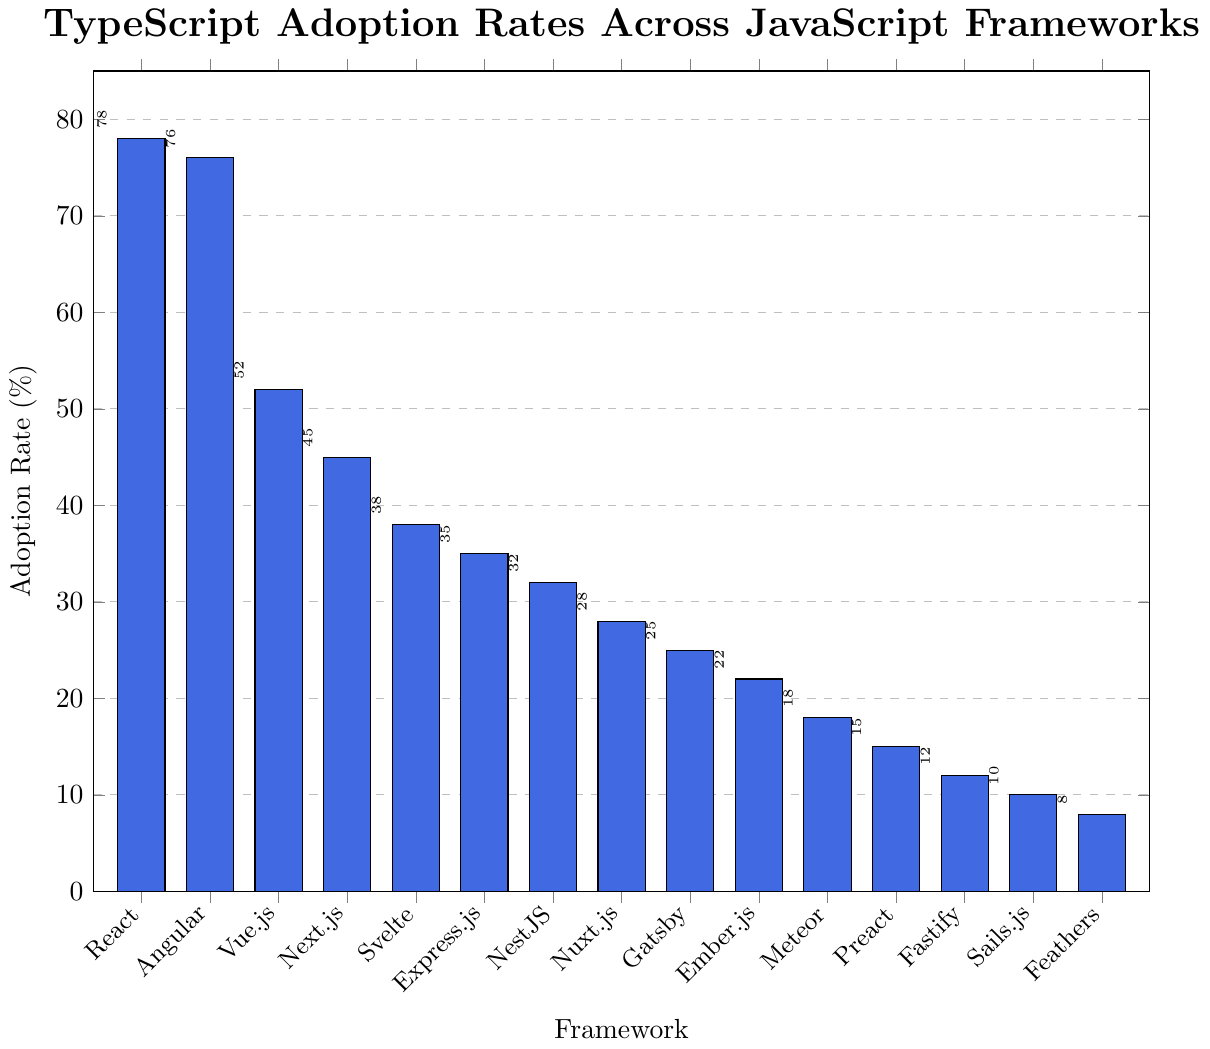What's the framework with the highest TypeScript adoption rate? The highest bar in the chart corresponds to the framework with the highest adoption rate. In this case, the tallest bar represents React with an adoption rate of 78%.
Answer: React Which framework has a lower TypeScript adoption rate, Angular or Vue.js? To determine which framework has a lower adoption rate, compare the heights of the bars for Angular and Vue.js. Angular has an adoption rate of 76%, while Vue.js has 52%. Hence, Vue.js has a lower adoption rate.
Answer: Vue.js What is the total adoption rate for the top three frameworks? The top three frameworks in terms of adoption rate are React (78%), Angular (76%), and Vue.js (52%). Summing these values: 78% + 76% + 52% = 206%.
Answer: 206% How much higher is Next.js's adoption rate compared to Fastify's? Subtract the adoption rate of Fastify (12%) from that of Next.js (45%): 45% - 12% = 33%. Thus, Next.js's adoption rate is 33% higher than Fastify's.
Answer: 33% Which framework has the median TypeScript adoption rate and what is its value? To find the median, list the adoption rates in ascending order: 8%, 10%, 12%, 15%, 18%, 22%, 25%, 28%, 32%, 35%, 38%, 45%, 52%, 76%, 78%. The median value (the middle value in this list) is the 8th value, 28%, corresponding to Nuxt.js.
Answer: Nuxt.js Are there more frameworks with an adoption rate above 50% or below 50%? Count the frameworks with adoption rates above 50% (React, Angular, Vue.js) which are 3, and those below 50% (Next.js, Svelte, Express.js, NestJS, Nuxt.js, Gatsby, Ember.js, Meteor, Preact, Fastify, Sails.js, Feathers) which are 12. More frameworks have adoption rates below 50%.
Answer: Below 50% What is the difference in TypeScript adoption rate between Svelte and Express.js? Subtract the adoption rate of Express.js (35%) from that of Svelte (38%): 38% - 35% = 3%. The TypeScript adoption rate for Svelte is 3% higher than for Express.js.
Answer: 3% Among the frameworks with adoption rates below 20%, which framework has the highest rate? The frameworks with adoption rates below 20% are Meteor (18%), Preact (15%), Fastify (12%), Sails.js (10%), and Feathers (8%). Among these, Meteor has the highest adoption rate of 18%.
Answer: Meteor Which framework has the lowest TypeScript adoption rate? The shortest bar in the chart represents the framework with the lowest adoption rate. In this case, the bar corresponds to Feathers with an adoption rate of 8%.
Answer: Feathers 